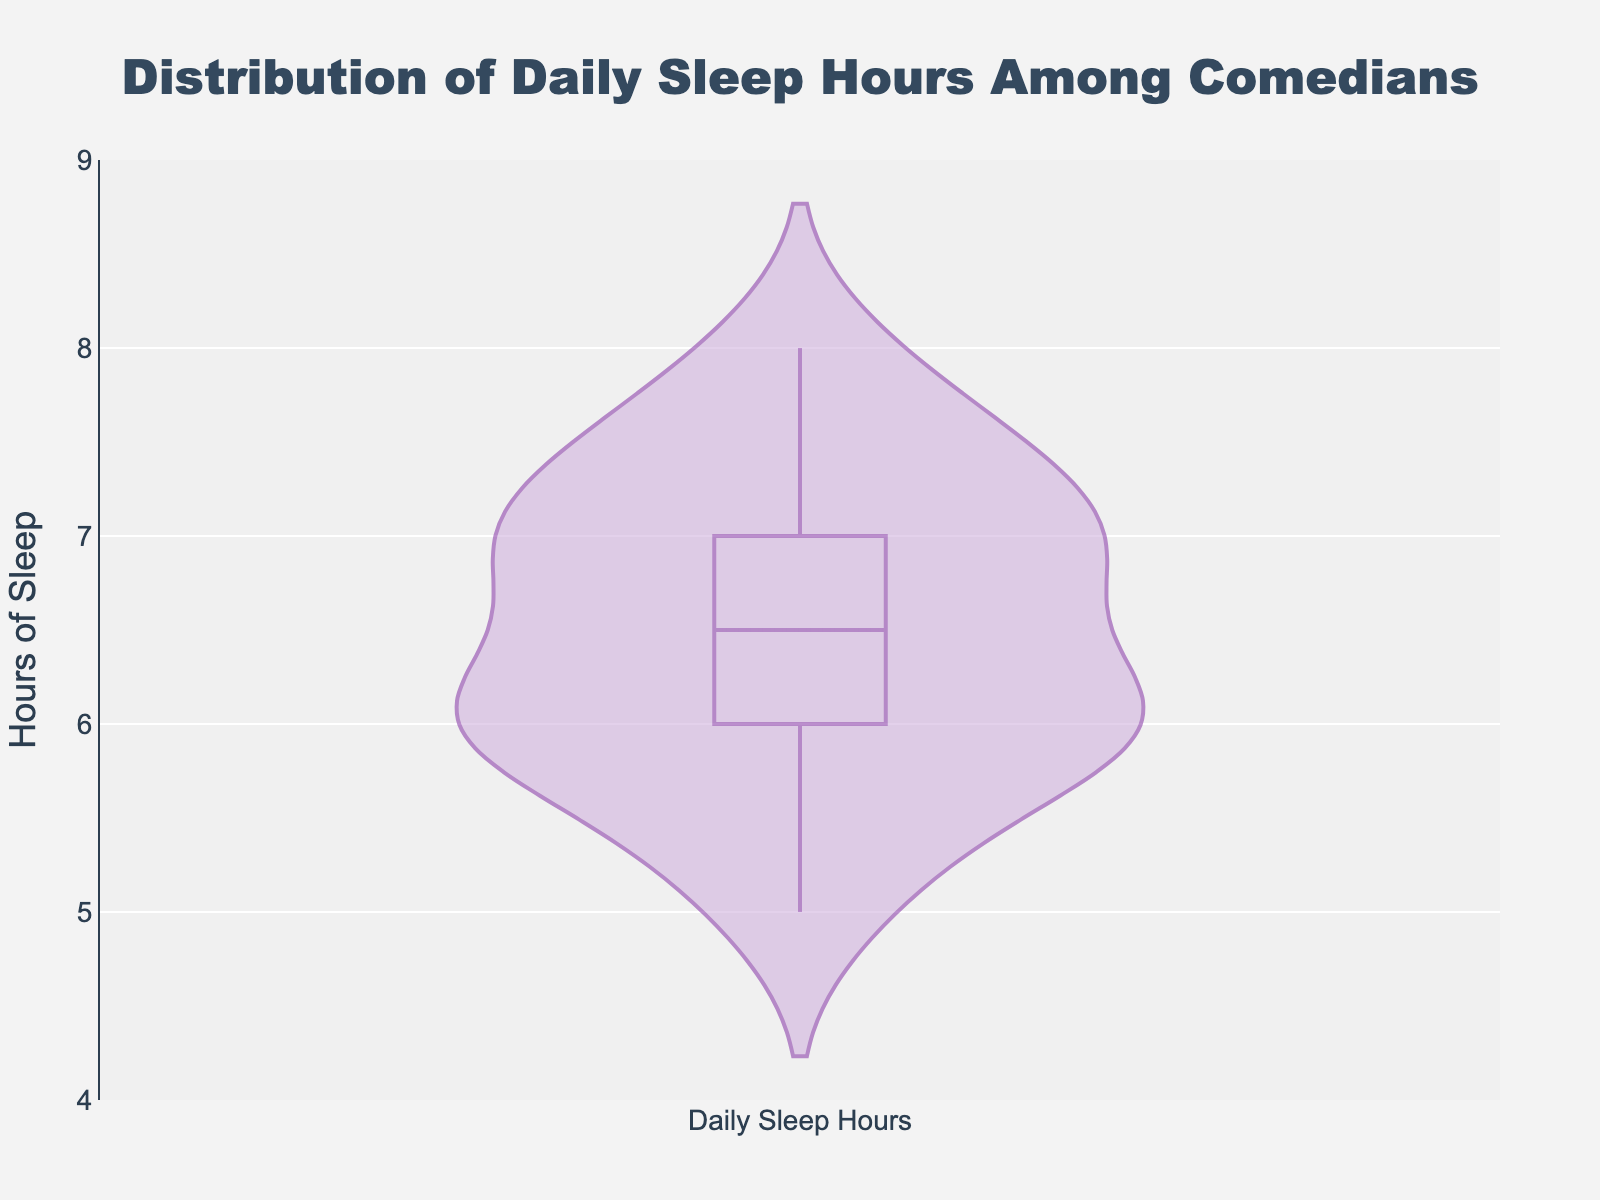What's the title of the figure? The title is located at the top of the figure and is usually written in a larger font size and different color.
Answer: Distribution of Daily Sleep Hours Among Comedians What is the range of the y-axis? The range of the y-axis is set explicitly in the chart properties, and it is visible along the left side of the chart. It goes from 4 to 9.
Answer: 4 to 9 How many comedians have daily sleep hours less than 6? By looking at the distribution in the violin plot, we count the data points that fall below the 6-hour mark.
Answer: 5 What is the median sleep duration according to the box plot overlay? The box plot indicates the median as a line inside the box, and it's located around the 6.5-hour mark.
Answer: 6.5 hours Which comedian sleeps the most hours? By examining the individual data points, the highest recorded value is 8 hours. Dave Chappelle and Chris Rock both have this value.
Answer: Dave Chappelle and Chris Rock What is the interquartile range (IQR) of the sleep hours? The IQR is the range between the first quartile (Q1) and the third quartile (Q3). In the box plot overlay, this spans from Q1 (6.0 hours) to Q3 (7.5 hours). Therefore, IQR = 7.5 - 6.0 = 1.5 hours.
Answer: 1.5 hours Based on the plot, which numerical value represents the peak density of sleep hours among comedians? The peak density in a violin plot is the widest part of the shape, which appears around the 7.0-hour mark.
Answer: 7 hours How many comedians have sleep hours exactly at the median? By observing the box plot overlay, there are multiple data points exactly at the median of 6.5 hours, which include comedians like Jerry Seinfeld, Kevin Hart, Michelle Wolf, Steve Martin, and Conan O'Brien.
Answer: 5 comedians Are there more comedians who sleep below or above the median sleep hours? To answer this, we compare the number of data points below and above the median line, which shows there are more comedians sleeping above 6.5 hours.
Answer: More sleep above the median What is the mean sleep duration according to the violin plot? The violin plot has an overlay indicating the mean, which is visible on the figure. The mean line is around the 6.5 - 7 hour mark.
Answer: Around 6.75 hours 